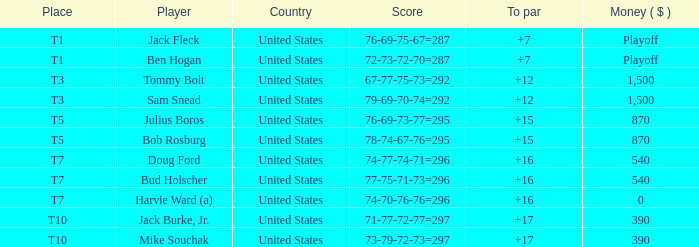What is average to par when Bud Holscher is the player? 16.0. Would you be able to parse every entry in this table? {'header': ['Place', 'Player', 'Country', 'Score', 'To par', 'Money ( $ )'], 'rows': [['T1', 'Jack Fleck', 'United States', '76-69-75-67=287', '+7', 'Playoff'], ['T1', 'Ben Hogan', 'United States', '72-73-72-70=287', '+7', 'Playoff'], ['T3', 'Tommy Bolt', 'United States', '67-77-75-73=292', '+12', '1,500'], ['T3', 'Sam Snead', 'United States', '79-69-70-74=292', '+12', '1,500'], ['T5', 'Julius Boros', 'United States', '76-69-73-77=295', '+15', '870'], ['T5', 'Bob Rosburg', 'United States', '78-74-67-76=295', '+15', '870'], ['T7', 'Doug Ford', 'United States', '74-77-74-71=296', '+16', '540'], ['T7', 'Bud Holscher', 'United States', '77-75-71-73=296', '+16', '540'], ['T7', 'Harvie Ward (a)', 'United States', '74-70-76-76=296', '+16', '0'], ['T10', 'Jack Burke, Jr.', 'United States', '71-77-72-77=297', '+17', '390'], ['T10', 'Mike Souchak', 'United States', '73-79-72-73=297', '+17', '390']]} 